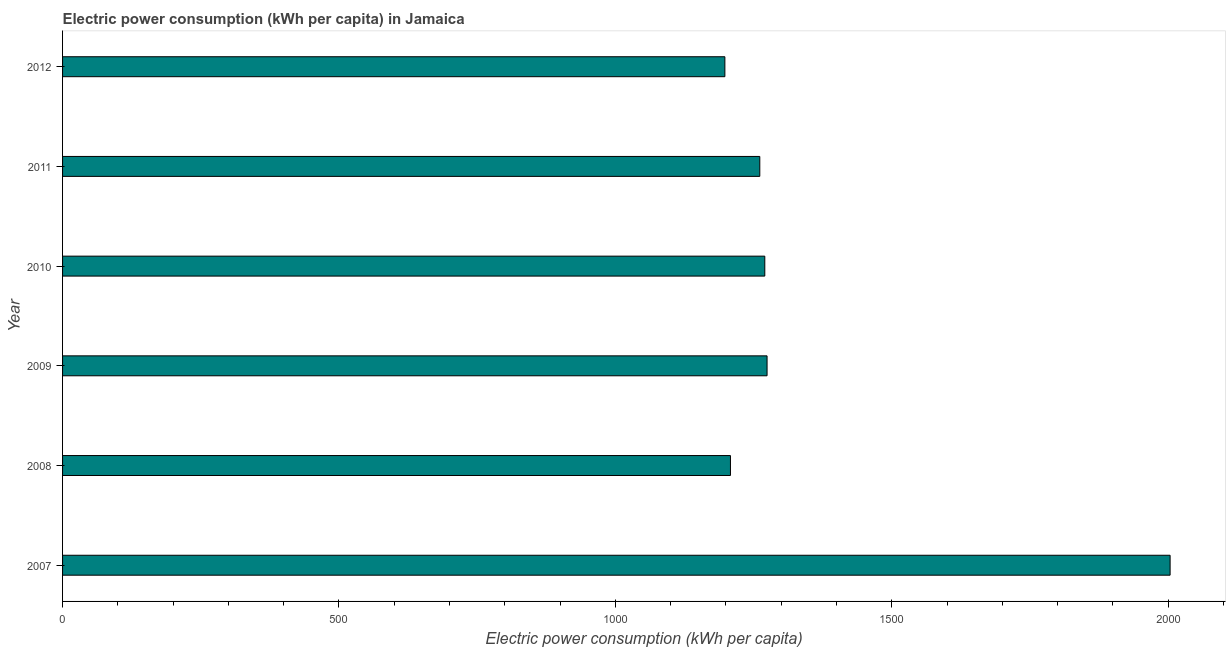Does the graph contain any zero values?
Provide a short and direct response. No. Does the graph contain grids?
Keep it short and to the point. No. What is the title of the graph?
Your response must be concise. Electric power consumption (kWh per capita) in Jamaica. What is the label or title of the X-axis?
Offer a very short reply. Electric power consumption (kWh per capita). What is the label or title of the Y-axis?
Make the answer very short. Year. What is the electric power consumption in 2007?
Your answer should be very brief. 2003.39. Across all years, what is the maximum electric power consumption?
Your response must be concise. 2003.39. Across all years, what is the minimum electric power consumption?
Your answer should be very brief. 1198.02. What is the sum of the electric power consumption?
Your answer should be compact. 8215.3. What is the difference between the electric power consumption in 2007 and 2009?
Your response must be concise. 729.05. What is the average electric power consumption per year?
Offer a terse response. 1369.22. What is the median electric power consumption?
Ensure brevity in your answer.  1265.71. In how many years, is the electric power consumption greater than 800 kWh per capita?
Offer a terse response. 6. Do a majority of the years between 2008 and 2012 (inclusive) have electric power consumption greater than 1300 kWh per capita?
Make the answer very short. No. What is the ratio of the electric power consumption in 2009 to that in 2011?
Offer a very short reply. 1.01. Is the electric power consumption in 2010 less than that in 2011?
Your answer should be compact. No. Is the difference between the electric power consumption in 2009 and 2012 greater than the difference between any two years?
Your answer should be compact. No. What is the difference between the highest and the second highest electric power consumption?
Keep it short and to the point. 729.05. What is the difference between the highest and the lowest electric power consumption?
Offer a terse response. 805.38. In how many years, is the electric power consumption greater than the average electric power consumption taken over all years?
Your answer should be very brief. 1. How many bars are there?
Ensure brevity in your answer.  6. Are all the bars in the graph horizontal?
Give a very brief answer. Yes. What is the Electric power consumption (kWh per capita) in 2007?
Your answer should be compact. 2003.39. What is the Electric power consumption (kWh per capita) of 2008?
Provide a short and direct response. 1208.11. What is the Electric power consumption (kWh per capita) in 2009?
Your response must be concise. 1274.34. What is the Electric power consumption (kWh per capita) of 2010?
Your response must be concise. 1270.24. What is the Electric power consumption (kWh per capita) in 2011?
Offer a very short reply. 1261.19. What is the Electric power consumption (kWh per capita) of 2012?
Your answer should be compact. 1198.02. What is the difference between the Electric power consumption (kWh per capita) in 2007 and 2008?
Your answer should be very brief. 795.28. What is the difference between the Electric power consumption (kWh per capita) in 2007 and 2009?
Your answer should be very brief. 729.05. What is the difference between the Electric power consumption (kWh per capita) in 2007 and 2010?
Your answer should be compact. 733.15. What is the difference between the Electric power consumption (kWh per capita) in 2007 and 2011?
Ensure brevity in your answer.  742.21. What is the difference between the Electric power consumption (kWh per capita) in 2007 and 2012?
Your response must be concise. 805.38. What is the difference between the Electric power consumption (kWh per capita) in 2008 and 2009?
Provide a short and direct response. -66.23. What is the difference between the Electric power consumption (kWh per capita) in 2008 and 2010?
Make the answer very short. -62.13. What is the difference between the Electric power consumption (kWh per capita) in 2008 and 2011?
Offer a very short reply. -53.07. What is the difference between the Electric power consumption (kWh per capita) in 2008 and 2012?
Offer a very short reply. 10.1. What is the difference between the Electric power consumption (kWh per capita) in 2009 and 2010?
Your response must be concise. 4.1. What is the difference between the Electric power consumption (kWh per capita) in 2009 and 2011?
Your answer should be compact. 13.15. What is the difference between the Electric power consumption (kWh per capita) in 2009 and 2012?
Provide a short and direct response. 76.32. What is the difference between the Electric power consumption (kWh per capita) in 2010 and 2011?
Offer a terse response. 9.06. What is the difference between the Electric power consumption (kWh per capita) in 2010 and 2012?
Keep it short and to the point. 72.22. What is the difference between the Electric power consumption (kWh per capita) in 2011 and 2012?
Provide a succinct answer. 63.17. What is the ratio of the Electric power consumption (kWh per capita) in 2007 to that in 2008?
Your answer should be very brief. 1.66. What is the ratio of the Electric power consumption (kWh per capita) in 2007 to that in 2009?
Provide a succinct answer. 1.57. What is the ratio of the Electric power consumption (kWh per capita) in 2007 to that in 2010?
Your answer should be compact. 1.58. What is the ratio of the Electric power consumption (kWh per capita) in 2007 to that in 2011?
Your answer should be compact. 1.59. What is the ratio of the Electric power consumption (kWh per capita) in 2007 to that in 2012?
Give a very brief answer. 1.67. What is the ratio of the Electric power consumption (kWh per capita) in 2008 to that in 2009?
Ensure brevity in your answer.  0.95. What is the ratio of the Electric power consumption (kWh per capita) in 2008 to that in 2010?
Provide a short and direct response. 0.95. What is the ratio of the Electric power consumption (kWh per capita) in 2008 to that in 2011?
Provide a succinct answer. 0.96. What is the ratio of the Electric power consumption (kWh per capita) in 2009 to that in 2011?
Your answer should be very brief. 1.01. What is the ratio of the Electric power consumption (kWh per capita) in 2009 to that in 2012?
Your response must be concise. 1.06. What is the ratio of the Electric power consumption (kWh per capita) in 2010 to that in 2012?
Offer a terse response. 1.06. What is the ratio of the Electric power consumption (kWh per capita) in 2011 to that in 2012?
Your answer should be very brief. 1.05. 